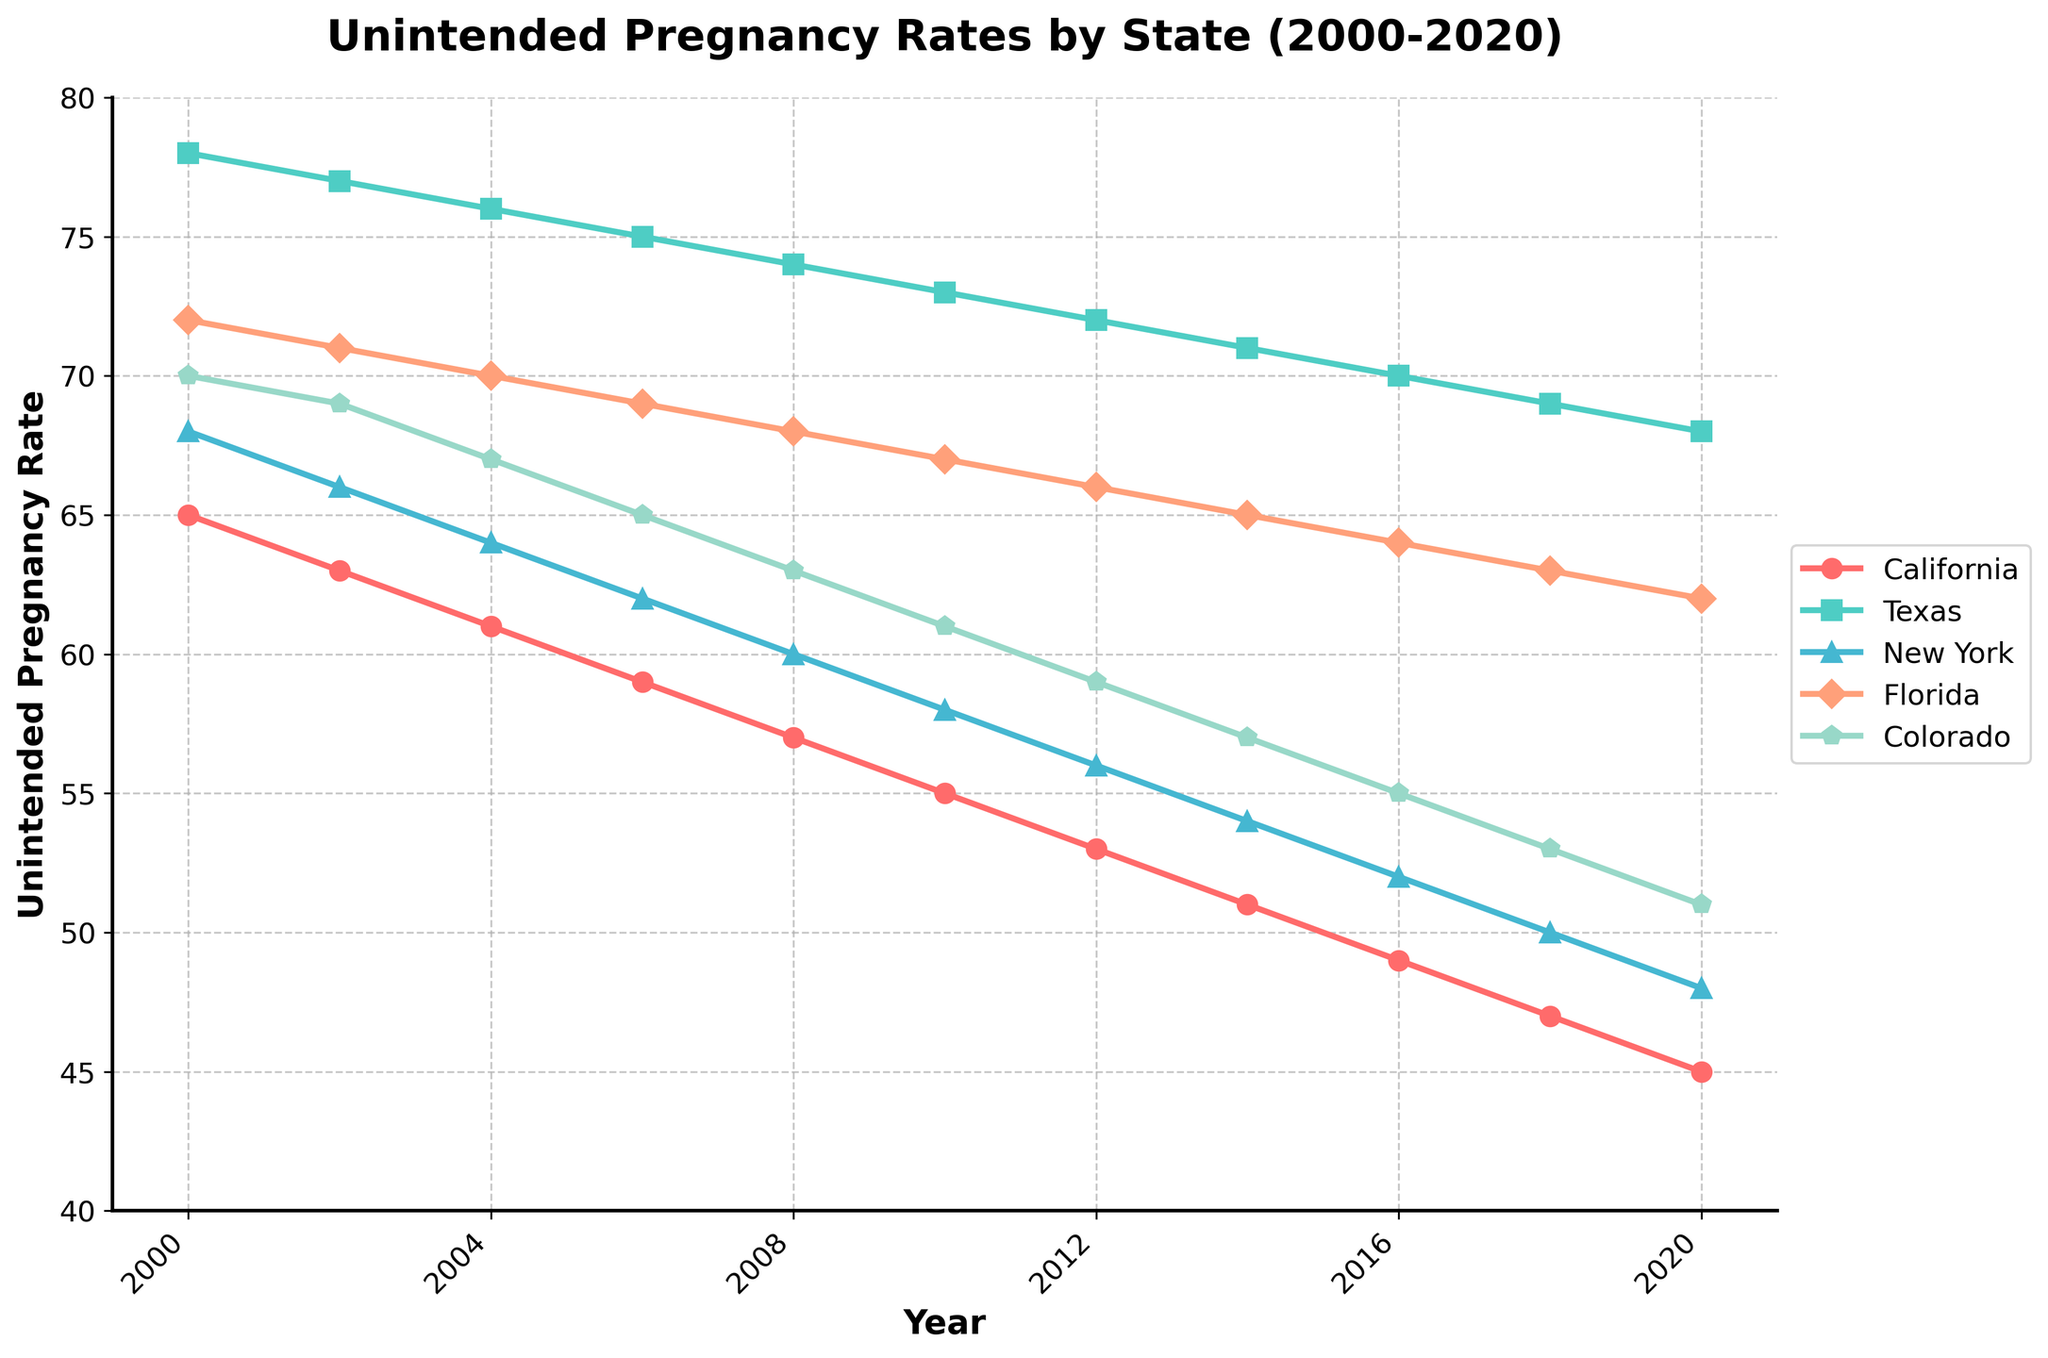Which state had the highest unintended pregnancy rate in 2020? To find the state with the highest unintended pregnancy rate in 2020, look at the line chart for the year 2020 and identify the state with the highest point on the y-axis.
Answer: Texas Which state showed the greatest decrease in unintended pregnancy rate from 2000 to 2020? To determine the greatest decrease, check the y-axis values for each state in 2000 and 2020. Calculate the difference for each state, then identify the state with the largest difference.
Answer: California Between which consecutive years did Florida's unintended pregnancy rate decrease the most? To find the years with the biggest decrease in Florida, examine the Florida line between consecutive points and find the pair with the largest drop on the y-axis.
Answer: 2002-2004 What is the average unintended pregnancy rate for Colorado over the two decades? Sum the unintended pregnancy rates for Colorado from 2000 to 2020 and divide by the number of years (11). (70 + 69 + 67 + 65 + 63 + 61 + 59 + 57 + 55 + 53 + 51) = 670/11 ≈ 60.9
Answer: 60.9 How does California's unintended pregnancy rate compare to New York's in 2004? Look at the line chart for 2004 and compare the y-axis values for California and New York.
Answer: California's rate is lower Which state had the smallest variance in unintended pregnancy rates over the years? To find the smallest variance, look at the fluctuations in the y-values for each state over the two decades. The state with the least fluctuation is the one with the smallest variance.
Answer: Texas What color represents Colorado's unintended pregnancy rates in the chart? Identify the color of the line representing Colorado by matching it with the key or legend in the chart.
Answer: Green What is the difference between the unintended pregnancy rates of Texas and Colorado in 2018? Find the points for Texas and Colorado in 2018 on the line chart and subtract Colorado's rate from Texas's rate. (69 - 53) = 16
Answer: 16 